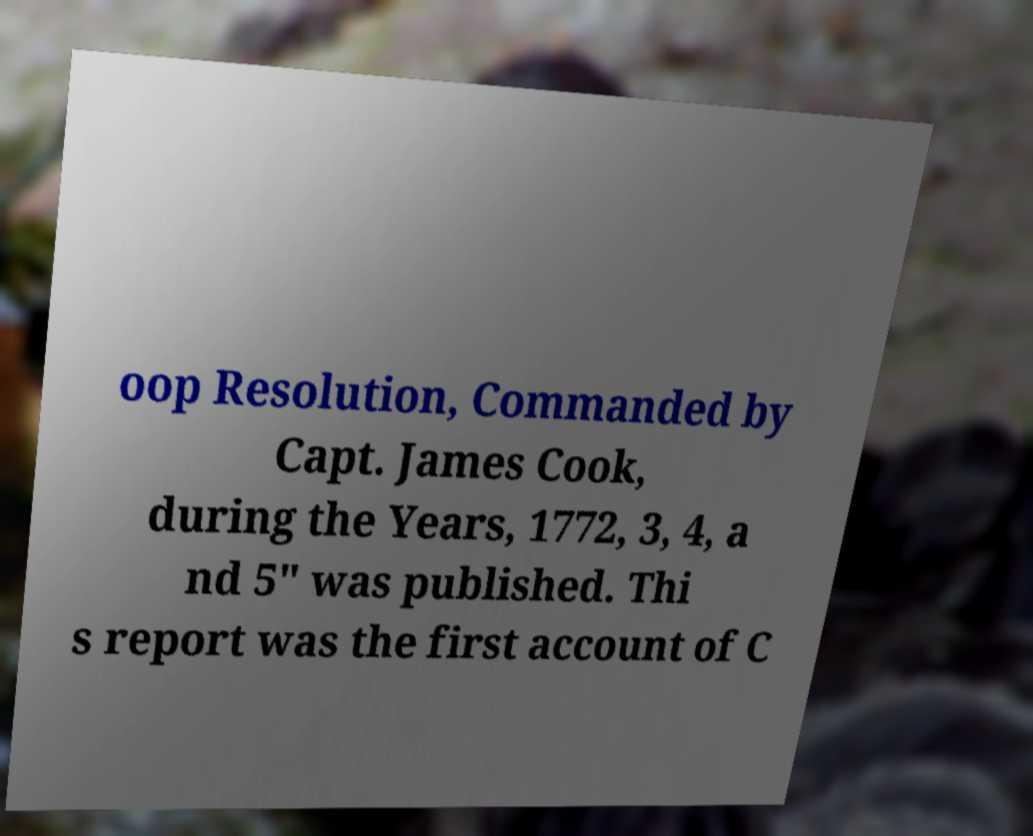Please read and relay the text visible in this image. What does it say? oop Resolution, Commanded by Capt. James Cook, during the Years, 1772, 3, 4, a nd 5" was published. Thi s report was the first account of C 